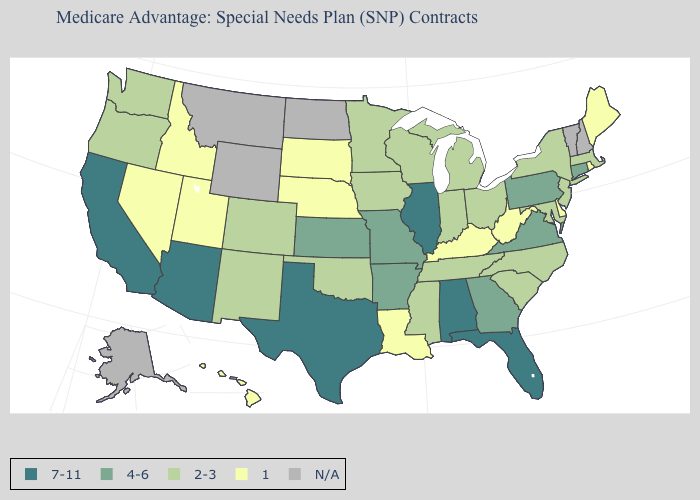What is the value of Massachusetts?
Concise answer only. 2-3. Which states have the lowest value in the MidWest?
Keep it brief. Nebraska, South Dakota. What is the highest value in the USA?
Short answer required. 7-11. Is the legend a continuous bar?
Quick response, please. No. What is the lowest value in the Northeast?
Concise answer only. 1. What is the highest value in the USA?
Write a very short answer. 7-11. Among the states that border Maryland , which have the lowest value?
Be succinct. Delaware, West Virginia. What is the value of Tennessee?
Be succinct. 2-3. What is the value of West Virginia?
Short answer required. 1. What is the value of South Carolina?
Keep it brief. 2-3. Does Maine have the highest value in the Northeast?
Concise answer only. No. Among the states that border Wisconsin , does Iowa have the highest value?
Concise answer only. No. What is the lowest value in the USA?
Be succinct. 1. Is the legend a continuous bar?
Be succinct. No. 